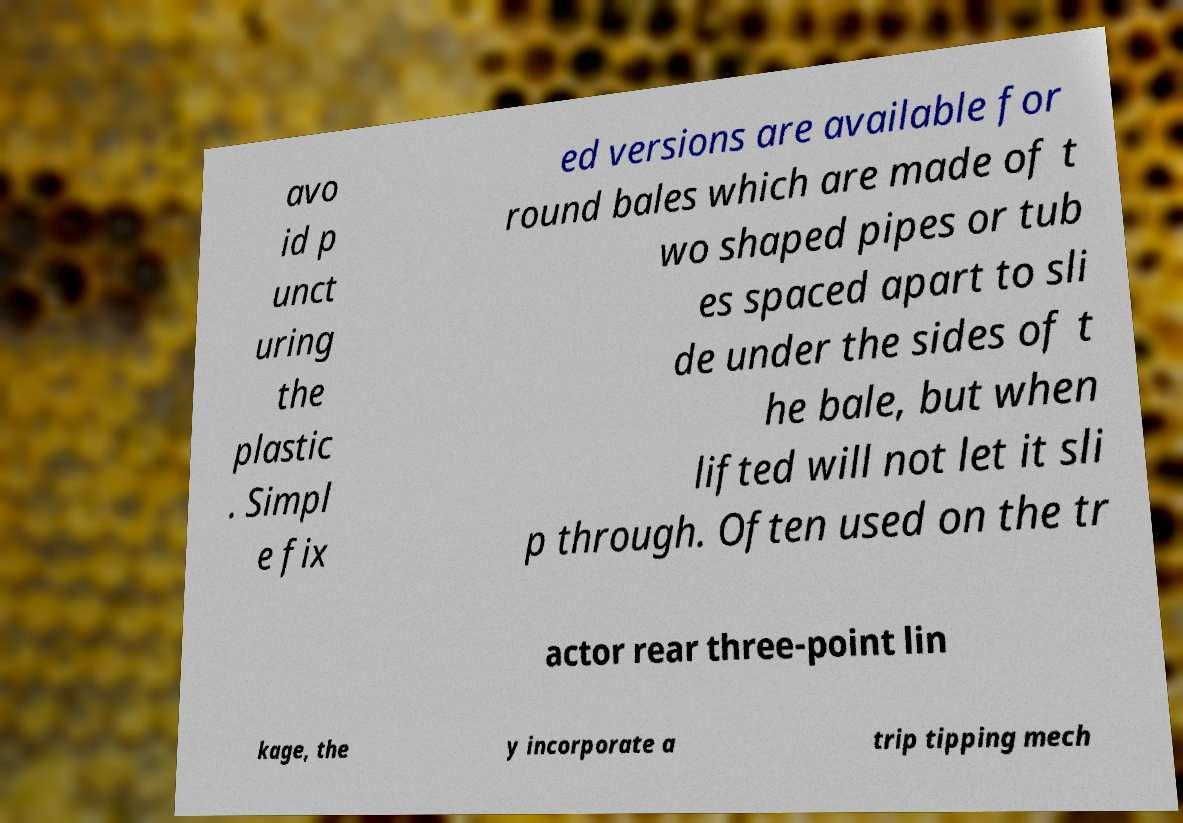Please read and relay the text visible in this image. What does it say? avo id p unct uring the plastic . Simpl e fix ed versions are available for round bales which are made of t wo shaped pipes or tub es spaced apart to sli de under the sides of t he bale, but when lifted will not let it sli p through. Often used on the tr actor rear three-point lin kage, the y incorporate a trip tipping mech 